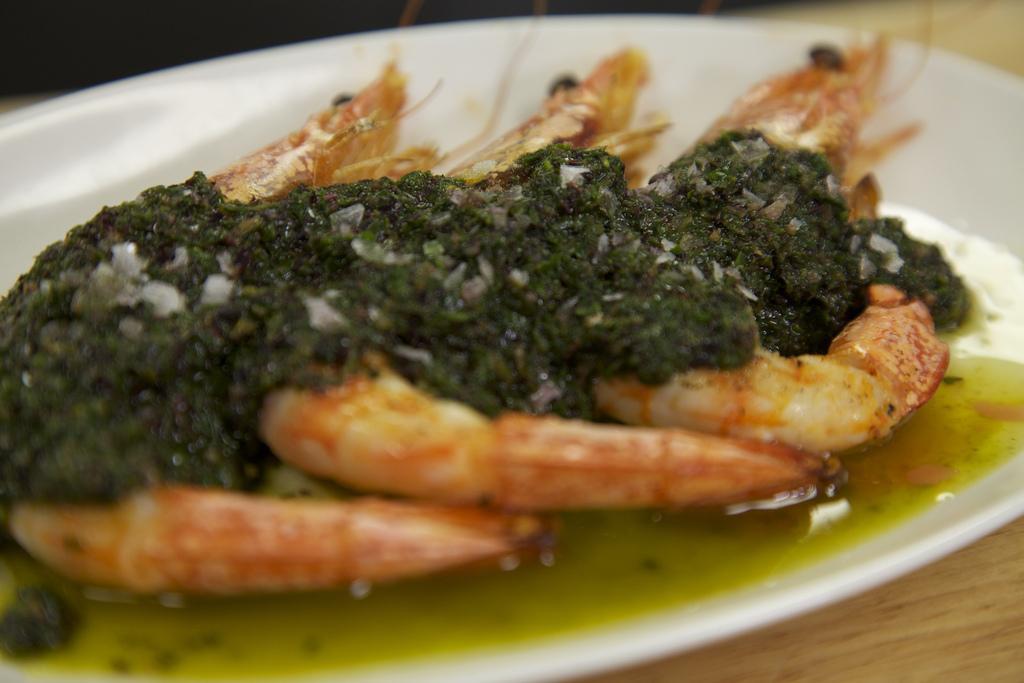How would you summarize this image in a sentence or two? In this image in the foreground there is one plate, on the plate there is some food and at the bottom there is table. 